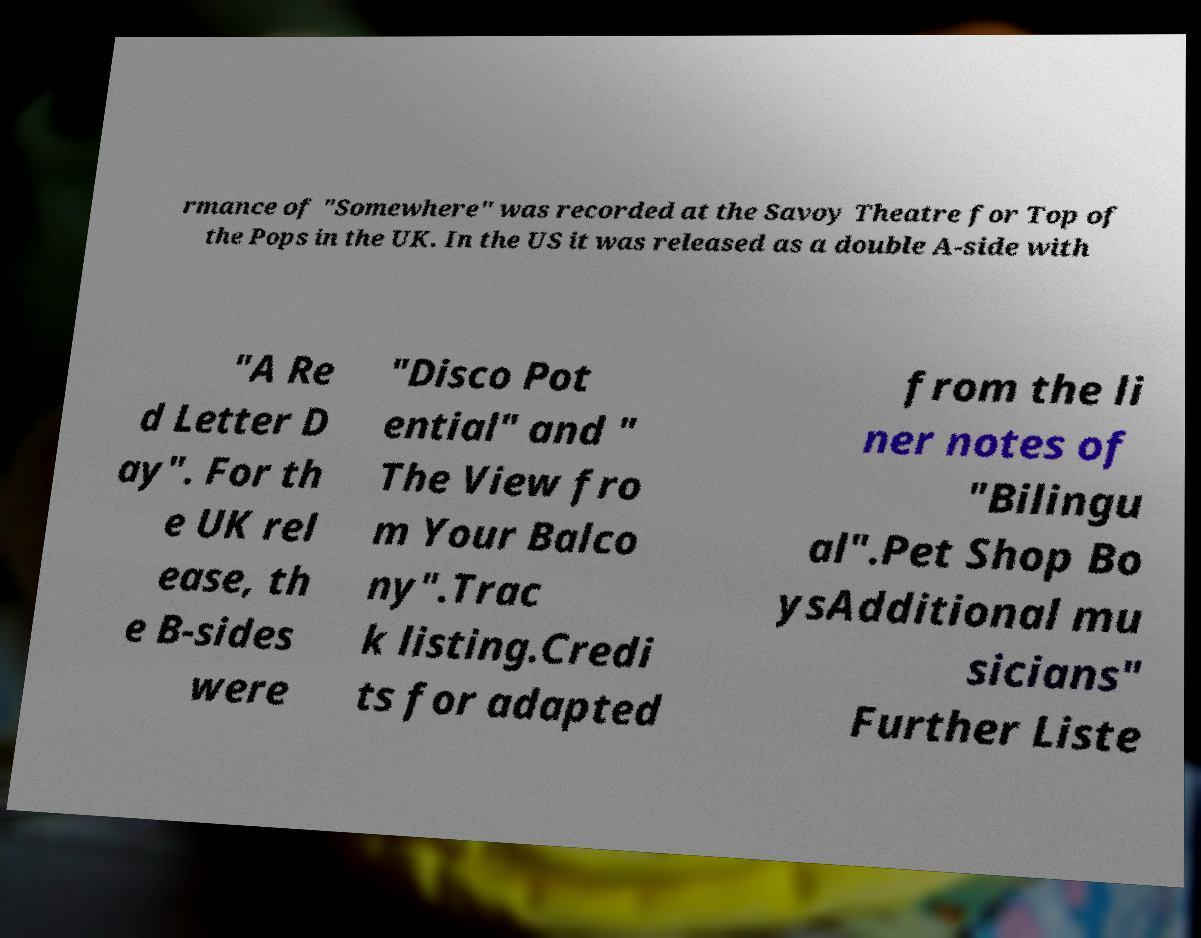I need the written content from this picture converted into text. Can you do that? rmance of "Somewhere" was recorded at the Savoy Theatre for Top of the Pops in the UK. In the US it was released as a double A-side with "A Re d Letter D ay". For th e UK rel ease, th e B-sides were "Disco Pot ential" and " The View fro m Your Balco ny".Trac k listing.Credi ts for adapted from the li ner notes of "Bilingu al".Pet Shop Bo ysAdditional mu sicians" Further Liste 